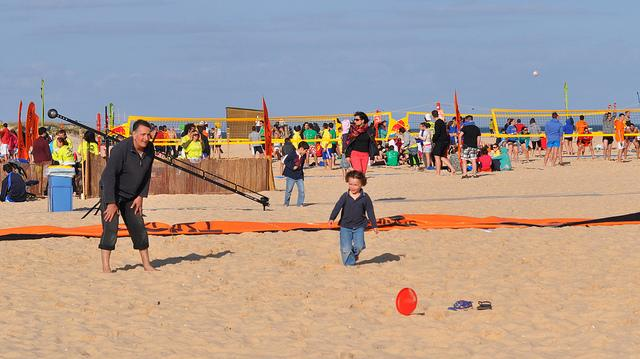What do they want to prevent the ball from touching? sand 